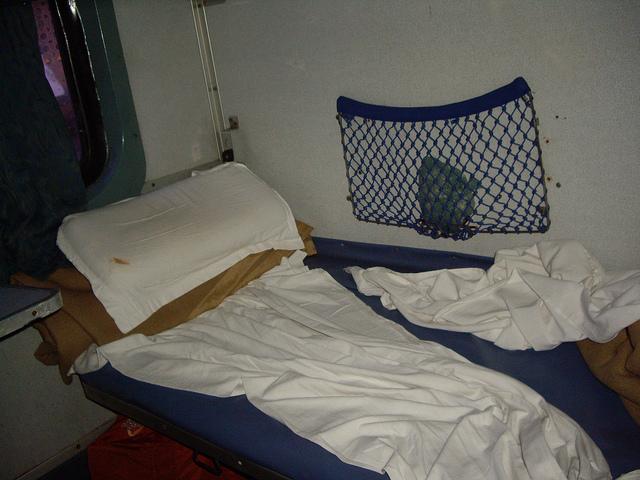What color is the lever under the bed?
Give a very brief answer. Red. What is in the picture?
Quick response, please. Bed. What is the ratio of white pillows to golden pillows?
Quick response, please. 1-1. Is the pillow clean?
Keep it brief. No. 